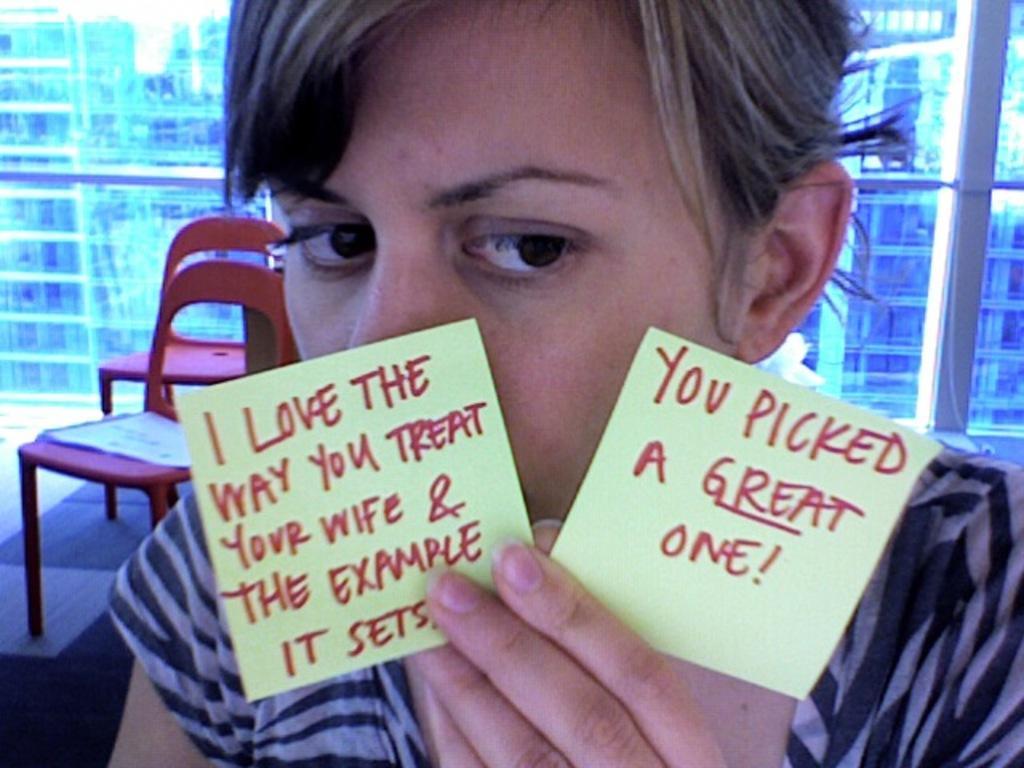Could you give a brief overview of what you see in this image? In the image there is a person in the foreground, the person is holding two slips with the hand and there are some sentences on the slips. Behind the person there are two empty chairs and in the background there are windows. 